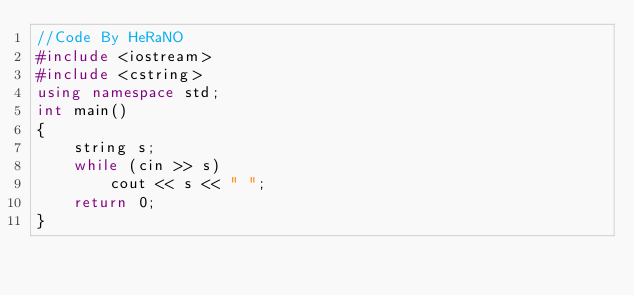<code> <loc_0><loc_0><loc_500><loc_500><_C++_>//Code By HeRaNO
#include <iostream>
#include <cstring>
using namespace std;
int main()
{
	string s;
	while (cin >> s)
		cout << s << " ";
	return 0;
}
</code> 